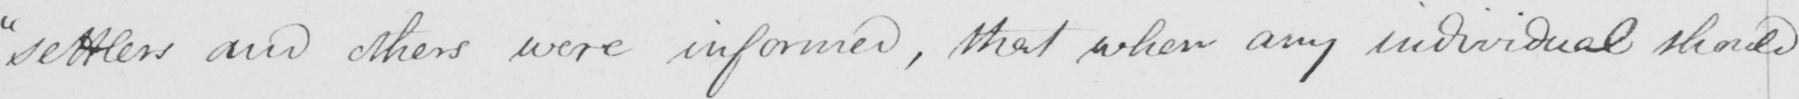What does this handwritten line say? "settlers and others were informed, that when any individual should 